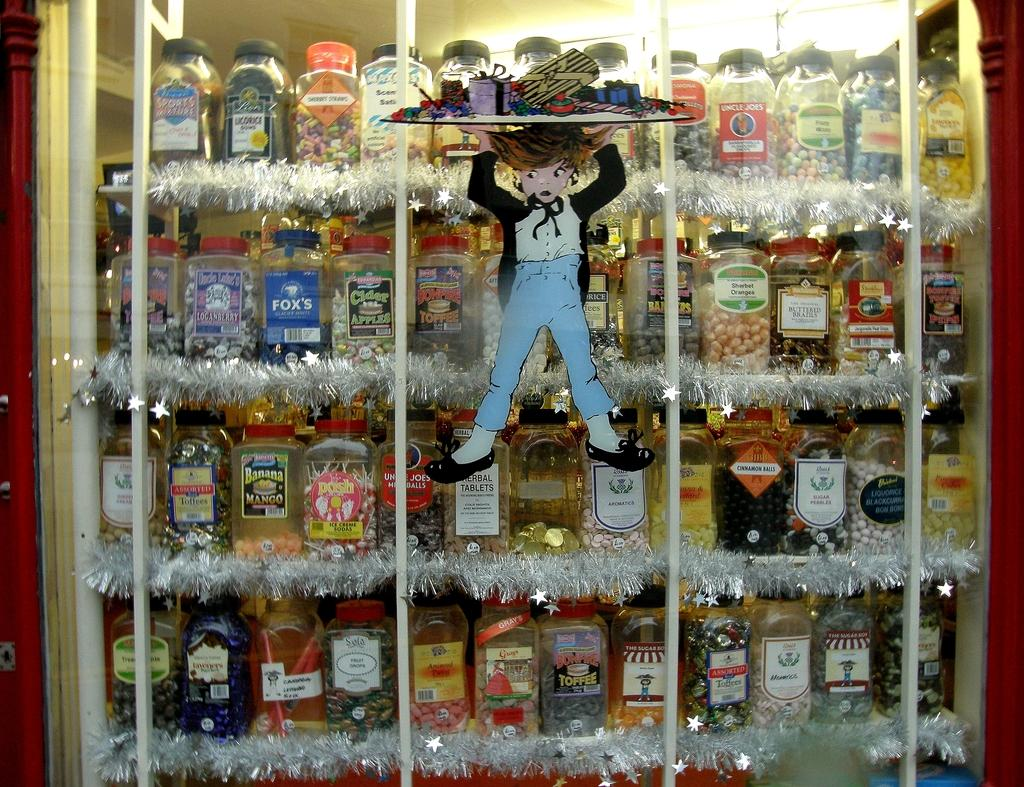<image>
Provide a brief description of the given image. bottles of posh and other liquers on shelves in a window 